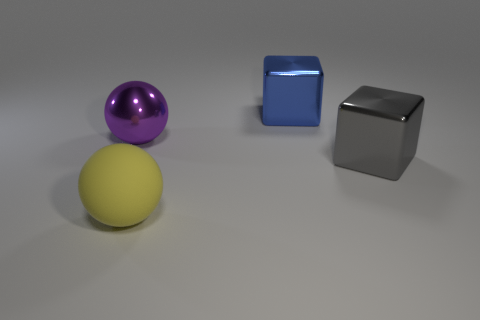How many objects are either balls that are in front of the gray metal block or large rubber spheres?
Make the answer very short. 1. How many other objects are there of the same size as the purple sphere?
Ensure brevity in your answer.  3. How big is the ball that is in front of the big gray object?
Your answer should be compact. Large. What is the shape of the large purple object that is made of the same material as the large gray thing?
Offer a terse response. Sphere. Are there any other things that are the same color as the large metallic ball?
Ensure brevity in your answer.  No. The big block in front of the large sphere behind the big yellow object is what color?
Keep it short and to the point. Gray. What number of big things are green shiny blocks or yellow matte balls?
Make the answer very short. 1. There is another object that is the same shape as the large purple object; what is its material?
Provide a succinct answer. Rubber. Is there any other thing that is the same material as the yellow object?
Offer a terse response. No. What is the color of the big rubber thing?
Give a very brief answer. Yellow. 